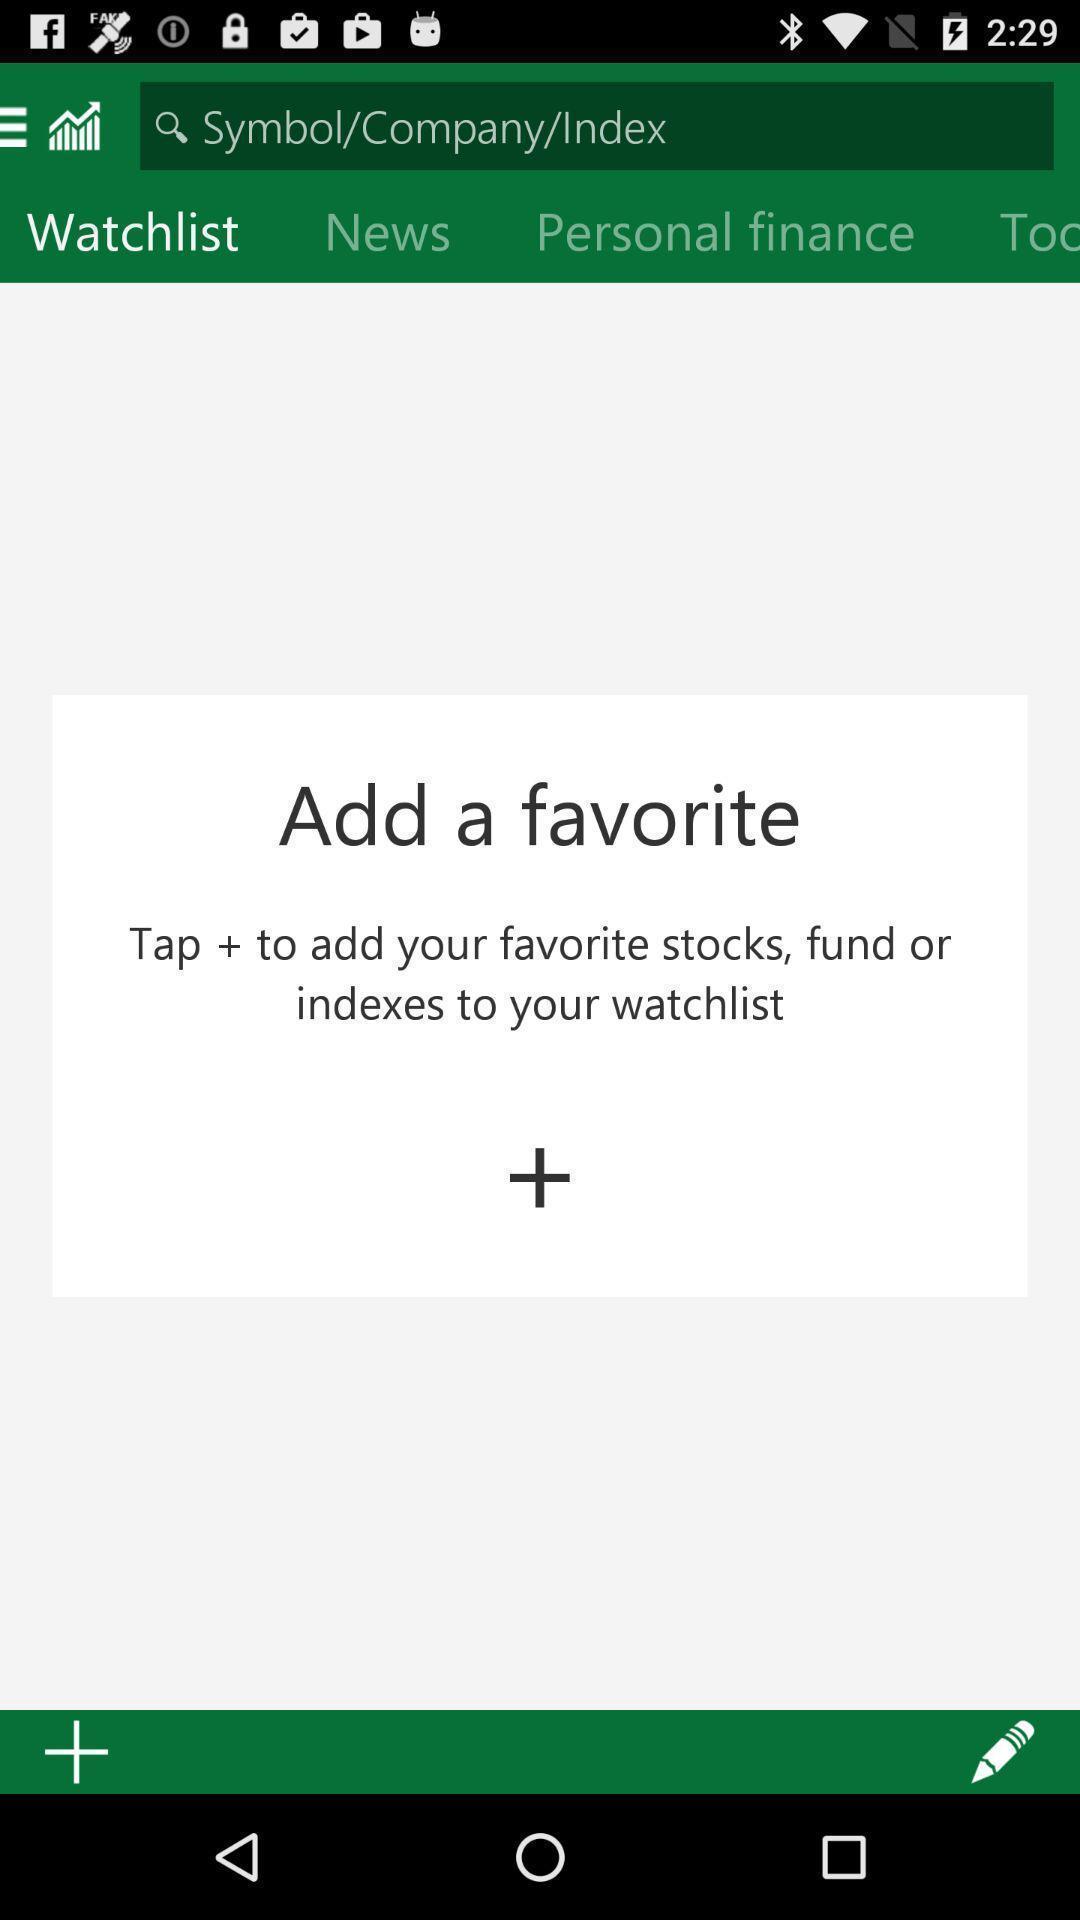Describe the content in this image. Screen showing watch list page of a financial app. 